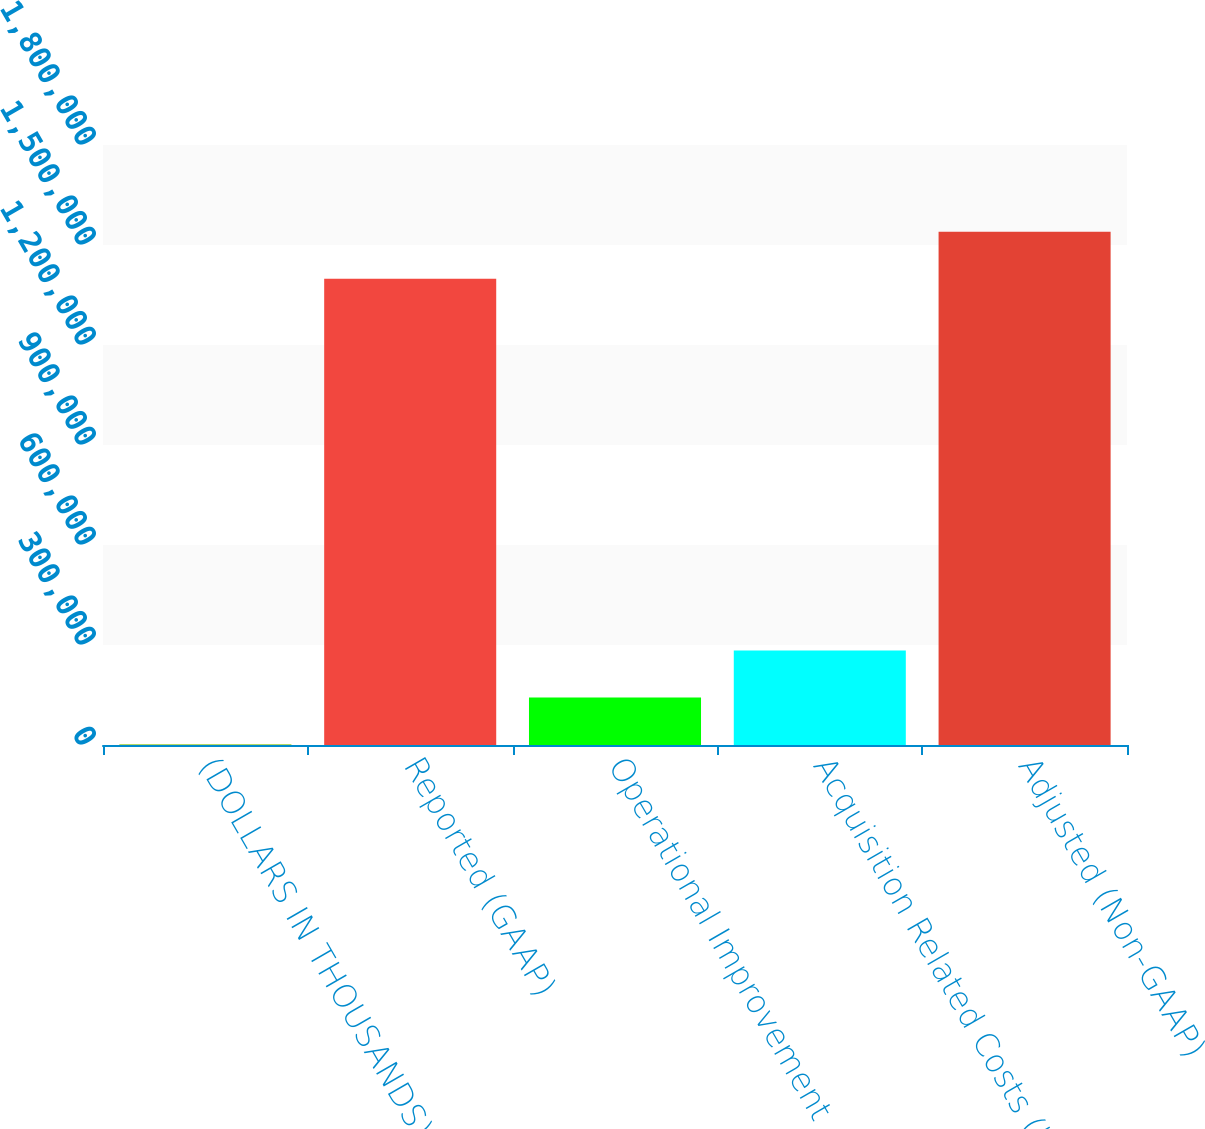<chart> <loc_0><loc_0><loc_500><loc_500><bar_chart><fcel>(DOLLARS IN THOUSANDS)<fcel>Reported (GAAP)<fcel>Operational Improvement<fcel>Acquisition Related Costs (b)<fcel>Adjusted (Non-GAAP)<nl><fcel>2016<fcel>1.39907e+06<fcel>142791<fcel>283566<fcel>1.53985e+06<nl></chart> 